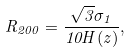<formula> <loc_0><loc_0><loc_500><loc_500>R _ { 2 0 0 } = \frac { \sqrt { 3 } \sigma _ { 1 } } { 1 0 H ( z ) } ,</formula> 